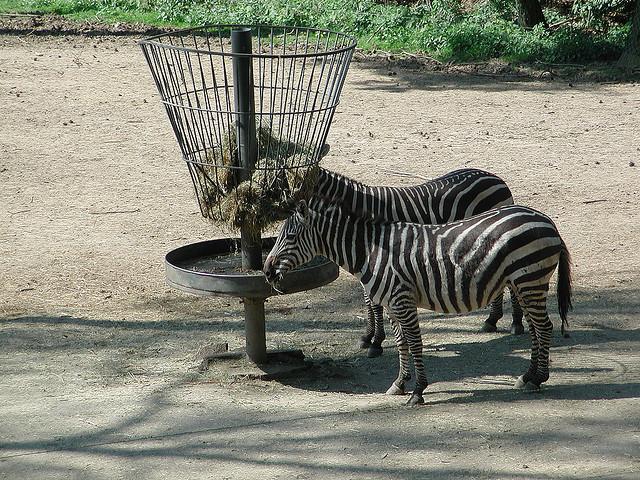What type of animals are these?
Give a very brief answer. Zebras. What other object does the feeder look like?
Short answer required. Basket. What have the animals been fed?
Quick response, please. Hay. 